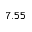<formula> <loc_0><loc_0><loc_500><loc_500>7 . 5 5</formula> 